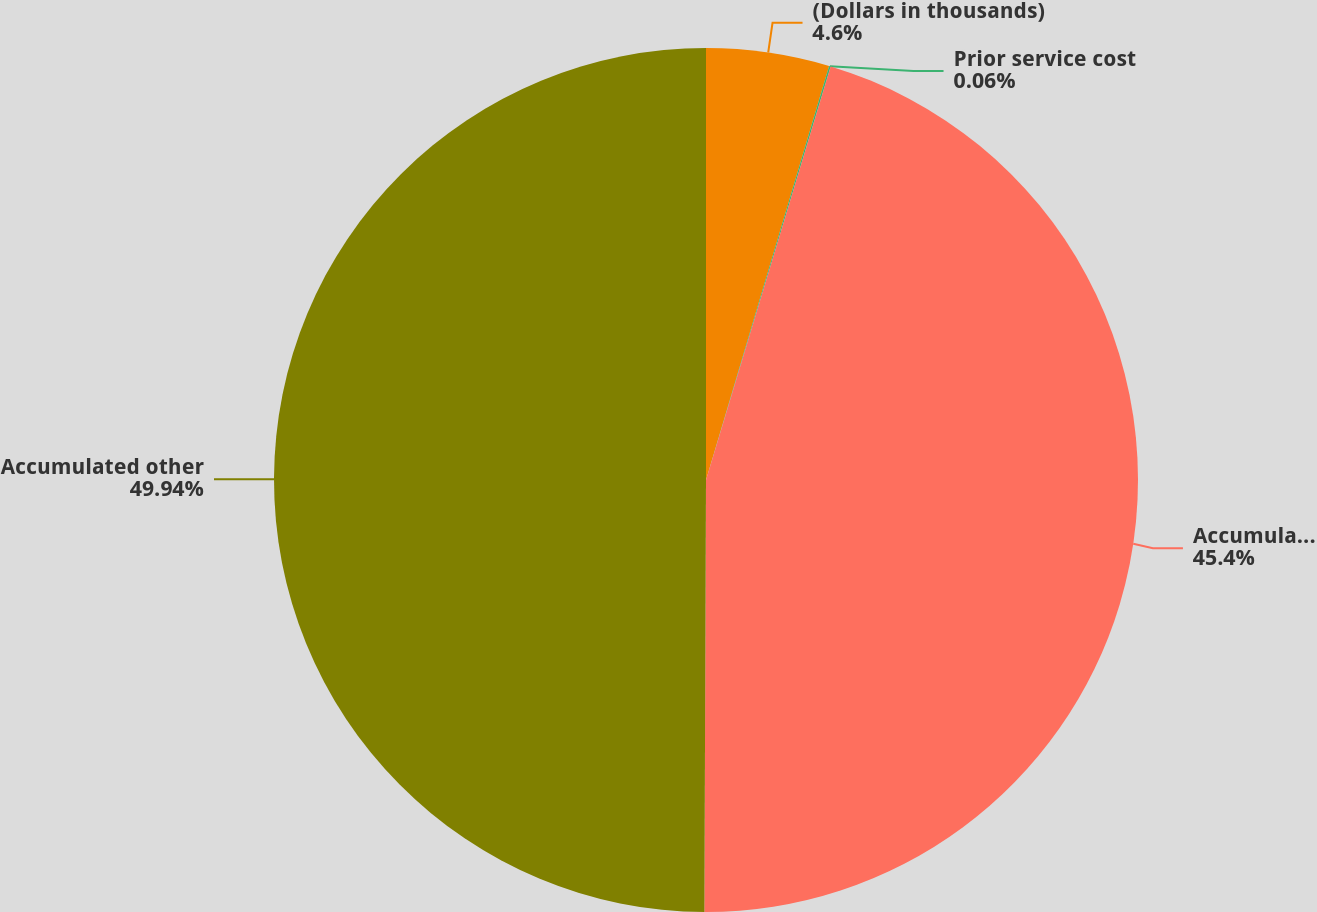<chart> <loc_0><loc_0><loc_500><loc_500><pie_chart><fcel>(Dollars in thousands)<fcel>Prior service cost<fcel>Accumulated income (loss)<fcel>Accumulated other<nl><fcel>4.6%<fcel>0.06%<fcel>45.4%<fcel>49.94%<nl></chart> 